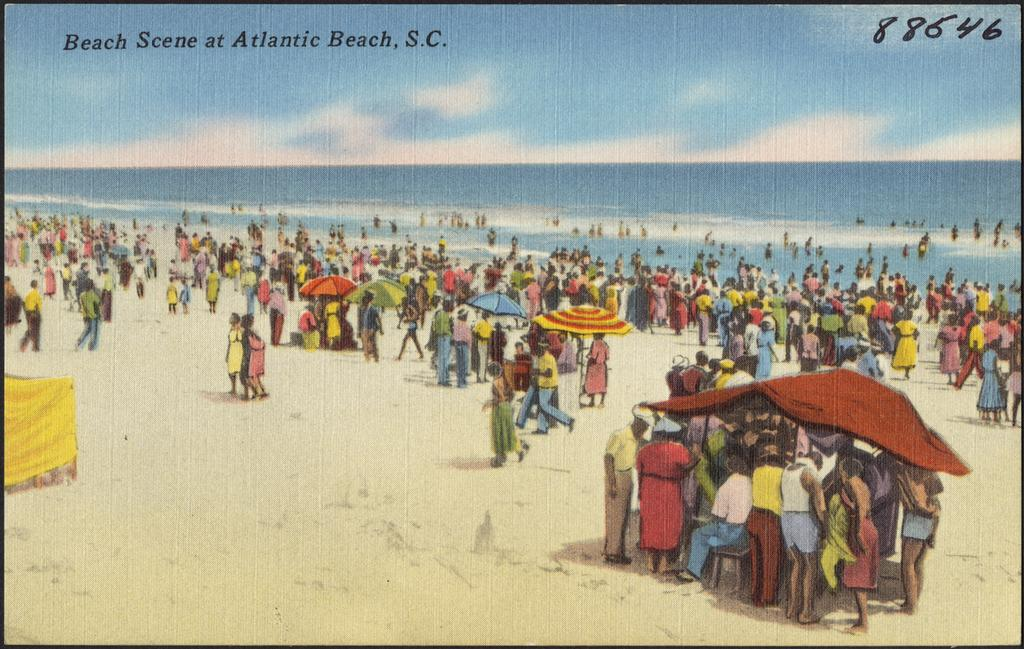<image>
Share a concise interpretation of the image provided. A beach scene of people at the Atlantic Beach in South Carolina. 